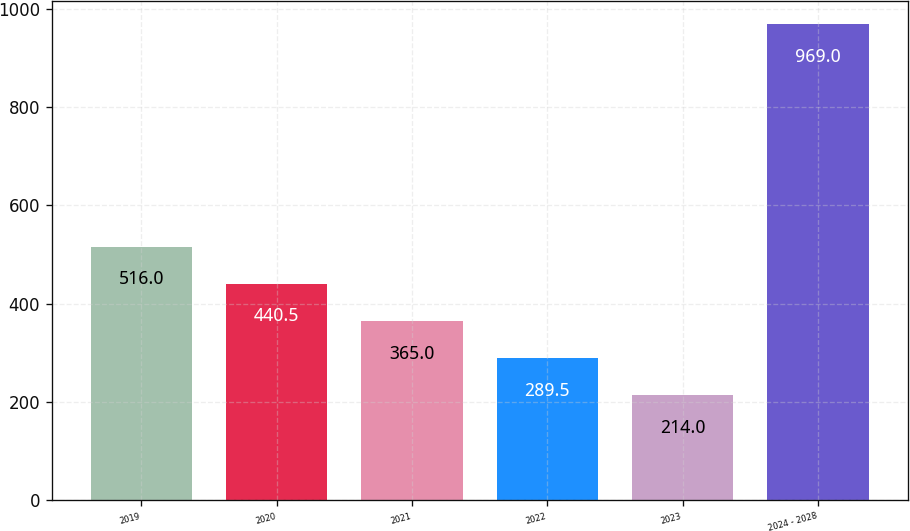Convert chart to OTSL. <chart><loc_0><loc_0><loc_500><loc_500><bar_chart><fcel>2019<fcel>2020<fcel>2021<fcel>2022<fcel>2023<fcel>2024 - 2028<nl><fcel>516<fcel>440.5<fcel>365<fcel>289.5<fcel>214<fcel>969<nl></chart> 